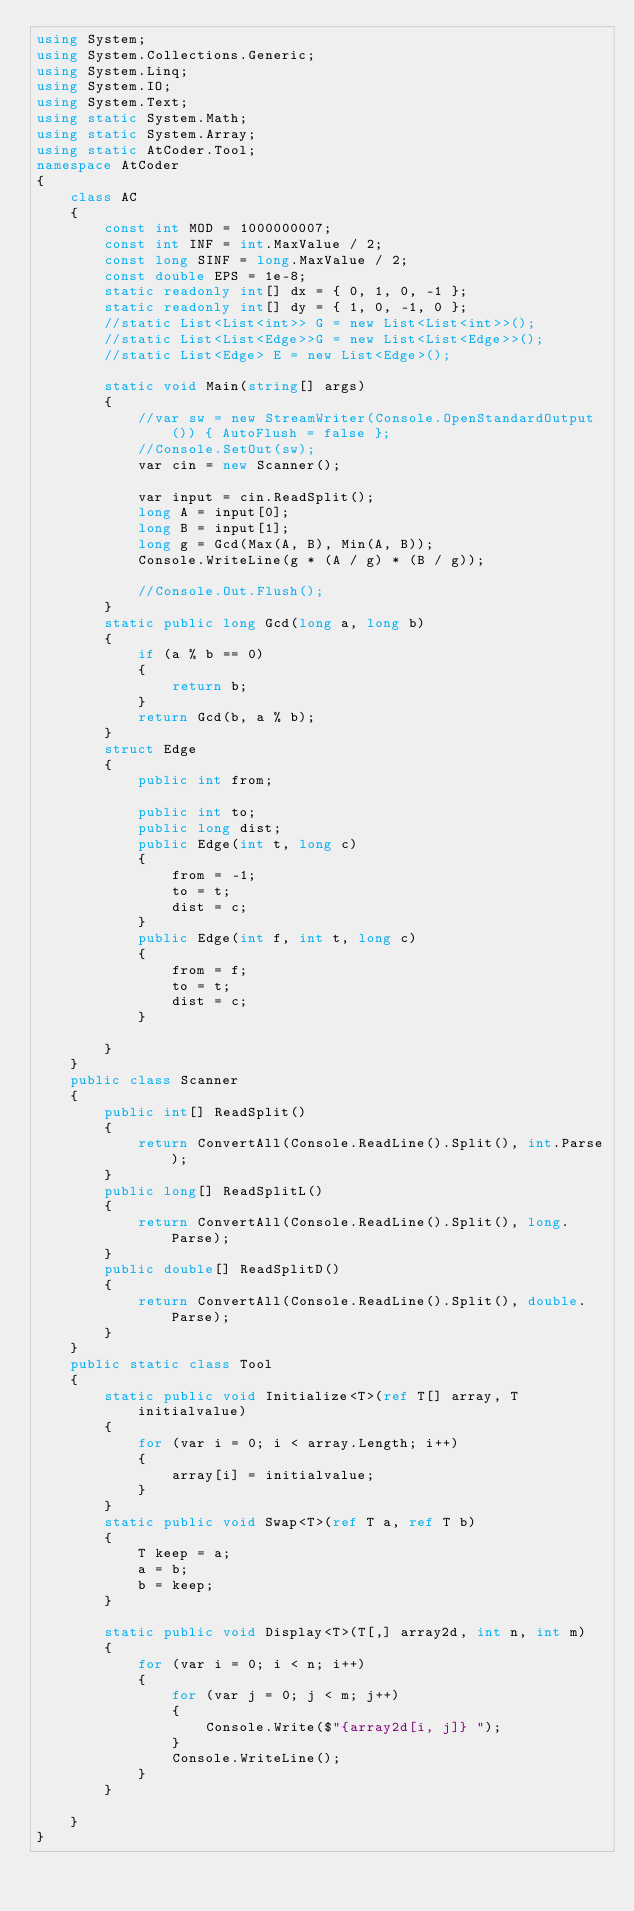<code> <loc_0><loc_0><loc_500><loc_500><_C#_>using System;
using System.Collections.Generic;
using System.Linq;
using System.IO;
using System.Text;
using static System.Math;
using static System.Array;
using static AtCoder.Tool;
namespace AtCoder
{
    class AC
    {
        const int MOD = 1000000007;
        const int INF = int.MaxValue / 2;
        const long SINF = long.MaxValue / 2;
        const double EPS = 1e-8;
        static readonly int[] dx = { 0, 1, 0, -1 };
        static readonly int[] dy = { 1, 0, -1, 0 };
        //static List<List<int>> G = new List<List<int>>();
        //static List<List<Edge>>G = new List<List<Edge>>();
        //static List<Edge> E = new List<Edge>();
        
        static void Main(string[] args)
        {
            //var sw = new StreamWriter(Console.OpenStandardOutput()) { AutoFlush = false };
            //Console.SetOut(sw);
            var cin = new Scanner();

            var input = cin.ReadSplit();
            long A = input[0];
            long B = input[1];
            long g = Gcd(Max(A, B), Min(A, B));
            Console.WriteLine(g * (A / g) * (B / g));

            //Console.Out.Flush();
        }
        static public long Gcd(long a, long b)
        {
            if (a % b == 0)
            {
                return b;
            }
            return Gcd(b, a % b);
        }
        struct Edge
        {
            public int from;

            public int to;
            public long dist;
            public Edge(int t, long c)
            {
                from = -1;
                to = t;
                dist = c;
            }
            public Edge(int f, int t, long c)
            {
                from = f;
                to = t;
                dist = c;
            }

        }
    }
    public class Scanner
    {
        public int[] ReadSplit()
        {
            return ConvertAll(Console.ReadLine().Split(), int.Parse);
        }
        public long[] ReadSplitL()
        {
            return ConvertAll(Console.ReadLine().Split(), long.Parse);
        }
        public double[] ReadSplitD()
        {
            return ConvertAll(Console.ReadLine().Split(), double.Parse);
        }
    }
    public static class Tool
    {
        static public void Initialize<T>(ref T[] array, T initialvalue)
        {
            for (var i = 0; i < array.Length; i++)
            {
                array[i] = initialvalue;
            }
        }
        static public void Swap<T>(ref T a, ref T b)
        {
            T keep = a;
            a = b;
            b = keep;
        }

        static public void Display<T>(T[,] array2d, int n, int m)
        {
            for (var i = 0; i < n; i++)
            {
                for (var j = 0; j < m; j++)
                {
                    Console.Write($"{array2d[i, j]} ");
                }
                Console.WriteLine();
            }
        }

    }
}
</code> 